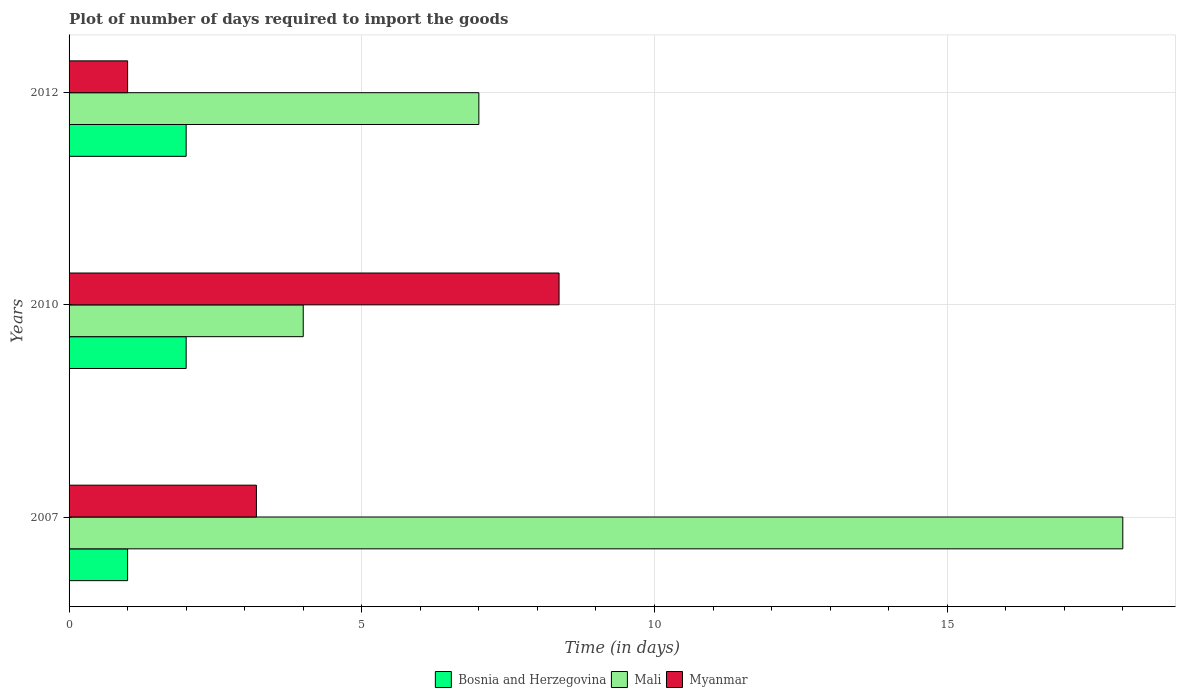How many groups of bars are there?
Provide a short and direct response. 3. What is the label of the 1st group of bars from the top?
Your answer should be compact. 2012. What is the time required to import goods in Bosnia and Herzegovina in 2007?
Offer a terse response. 1. Across all years, what is the maximum time required to import goods in Myanmar?
Your answer should be compact. 8.37. What is the total time required to import goods in Mali in the graph?
Keep it short and to the point. 29. What is the difference between the time required to import goods in Bosnia and Herzegovina in 2007 and that in 2010?
Make the answer very short. -1. What is the difference between the time required to import goods in Myanmar in 2010 and the time required to import goods in Mali in 2012?
Your answer should be very brief. 1.37. What is the average time required to import goods in Mali per year?
Offer a very short reply. 9.67. In the year 2010, what is the difference between the time required to import goods in Bosnia and Herzegovina and time required to import goods in Myanmar?
Make the answer very short. -6.37. In how many years, is the time required to import goods in Myanmar greater than 11 days?
Provide a short and direct response. 0. What is the ratio of the time required to import goods in Bosnia and Herzegovina in 2007 to that in 2010?
Make the answer very short. 0.5. Is the time required to import goods in Bosnia and Herzegovina in 2007 less than that in 2010?
Ensure brevity in your answer.  Yes. Is the difference between the time required to import goods in Bosnia and Herzegovina in 2007 and 2010 greater than the difference between the time required to import goods in Myanmar in 2007 and 2010?
Ensure brevity in your answer.  Yes. What is the difference between the highest and the second highest time required to import goods in Mali?
Your answer should be very brief. 11. What is the difference between the highest and the lowest time required to import goods in Mali?
Make the answer very short. 14. What does the 3rd bar from the top in 2007 represents?
Give a very brief answer. Bosnia and Herzegovina. What does the 2nd bar from the bottom in 2010 represents?
Provide a succinct answer. Mali. How many bars are there?
Your answer should be compact. 9. Are all the bars in the graph horizontal?
Your answer should be very brief. Yes. How many years are there in the graph?
Keep it short and to the point. 3. How many legend labels are there?
Offer a terse response. 3. How are the legend labels stacked?
Your response must be concise. Horizontal. What is the title of the graph?
Provide a short and direct response. Plot of number of days required to import the goods. What is the label or title of the X-axis?
Your response must be concise. Time (in days). What is the label or title of the Y-axis?
Your answer should be very brief. Years. What is the Time (in days) of Mali in 2007?
Your answer should be compact. 18. What is the Time (in days) of Mali in 2010?
Your answer should be very brief. 4. What is the Time (in days) of Myanmar in 2010?
Provide a short and direct response. 8.37. What is the Time (in days) in Bosnia and Herzegovina in 2012?
Offer a very short reply. 2. What is the Time (in days) of Mali in 2012?
Offer a very short reply. 7. What is the Time (in days) of Myanmar in 2012?
Provide a short and direct response. 1. Across all years, what is the maximum Time (in days) in Mali?
Keep it short and to the point. 18. Across all years, what is the maximum Time (in days) in Myanmar?
Provide a short and direct response. 8.37. Across all years, what is the minimum Time (in days) in Bosnia and Herzegovina?
Keep it short and to the point. 1. What is the total Time (in days) of Bosnia and Herzegovina in the graph?
Your answer should be compact. 5. What is the total Time (in days) in Mali in the graph?
Keep it short and to the point. 29. What is the total Time (in days) in Myanmar in the graph?
Provide a short and direct response. 12.57. What is the difference between the Time (in days) in Bosnia and Herzegovina in 2007 and that in 2010?
Offer a very short reply. -1. What is the difference between the Time (in days) of Mali in 2007 and that in 2010?
Offer a very short reply. 14. What is the difference between the Time (in days) of Myanmar in 2007 and that in 2010?
Offer a terse response. -5.17. What is the difference between the Time (in days) in Mali in 2010 and that in 2012?
Give a very brief answer. -3. What is the difference between the Time (in days) in Myanmar in 2010 and that in 2012?
Provide a succinct answer. 7.37. What is the difference between the Time (in days) of Bosnia and Herzegovina in 2007 and the Time (in days) of Mali in 2010?
Give a very brief answer. -3. What is the difference between the Time (in days) of Bosnia and Herzegovina in 2007 and the Time (in days) of Myanmar in 2010?
Provide a short and direct response. -7.37. What is the difference between the Time (in days) in Mali in 2007 and the Time (in days) in Myanmar in 2010?
Provide a succinct answer. 9.63. What is the difference between the Time (in days) in Mali in 2007 and the Time (in days) in Myanmar in 2012?
Your answer should be compact. 17. What is the average Time (in days) in Mali per year?
Your response must be concise. 9.67. What is the average Time (in days) in Myanmar per year?
Keep it short and to the point. 4.19. In the year 2007, what is the difference between the Time (in days) in Bosnia and Herzegovina and Time (in days) in Mali?
Ensure brevity in your answer.  -17. In the year 2010, what is the difference between the Time (in days) in Bosnia and Herzegovina and Time (in days) in Myanmar?
Your answer should be very brief. -6.37. In the year 2010, what is the difference between the Time (in days) in Mali and Time (in days) in Myanmar?
Your response must be concise. -4.37. In the year 2012, what is the difference between the Time (in days) in Bosnia and Herzegovina and Time (in days) in Mali?
Your answer should be compact. -5. What is the ratio of the Time (in days) of Mali in 2007 to that in 2010?
Offer a very short reply. 4.5. What is the ratio of the Time (in days) in Myanmar in 2007 to that in 2010?
Your answer should be compact. 0.38. What is the ratio of the Time (in days) in Bosnia and Herzegovina in 2007 to that in 2012?
Your answer should be very brief. 0.5. What is the ratio of the Time (in days) in Mali in 2007 to that in 2012?
Your response must be concise. 2.57. What is the ratio of the Time (in days) of Myanmar in 2007 to that in 2012?
Ensure brevity in your answer.  3.2. What is the ratio of the Time (in days) in Bosnia and Herzegovina in 2010 to that in 2012?
Your response must be concise. 1. What is the ratio of the Time (in days) of Myanmar in 2010 to that in 2012?
Ensure brevity in your answer.  8.37. What is the difference between the highest and the second highest Time (in days) of Bosnia and Herzegovina?
Offer a terse response. 0. What is the difference between the highest and the second highest Time (in days) of Mali?
Give a very brief answer. 11. What is the difference between the highest and the second highest Time (in days) of Myanmar?
Your answer should be compact. 5.17. What is the difference between the highest and the lowest Time (in days) in Bosnia and Herzegovina?
Offer a terse response. 1. What is the difference between the highest and the lowest Time (in days) in Mali?
Keep it short and to the point. 14. What is the difference between the highest and the lowest Time (in days) in Myanmar?
Your answer should be compact. 7.37. 